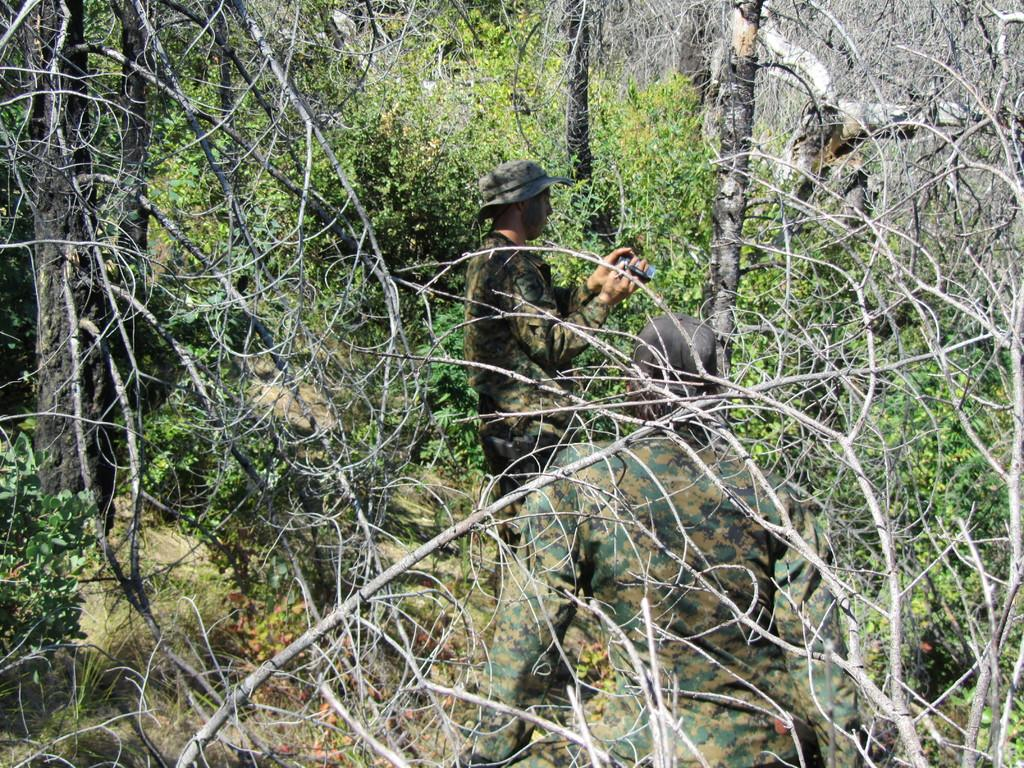How many people are in the image? There are two persons in the image. What is one of the persons holding? One of the persons is holding a camera. What can be seen in the background of the image? Trees are visible in the background of the image. What type of pie can be seen in the image? There is no pie present in the image. 